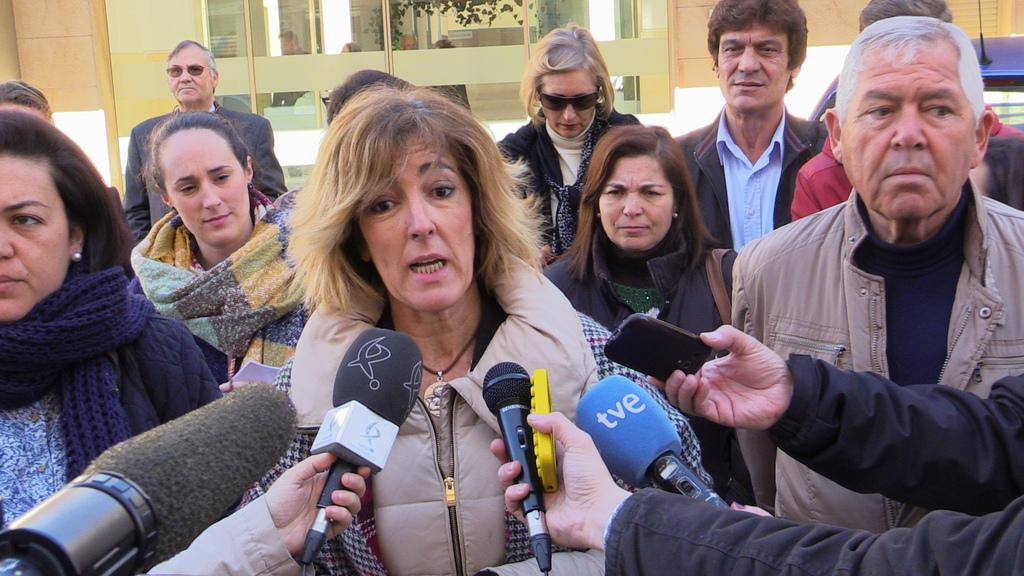What is located in the center of the image? There are persons, microphones, and mobile phones in the center of the image. What objects are being used by the persons in the image? The persons are using microphones and mobile phones in the image. What can be seen in the background of the image? There is a building, windows, and a car in the background of the image. How many ladybugs can be seen crawling on the microphones in the image? There are no ladybugs present in the image; it features persons, microphones, and mobile phones in the center, with a building, windows, and a car in the background. What type of brass instrument is being played by the persons in the image? There is no brass instrument present in the image; only microphones and mobile phones are being used by the persons. 